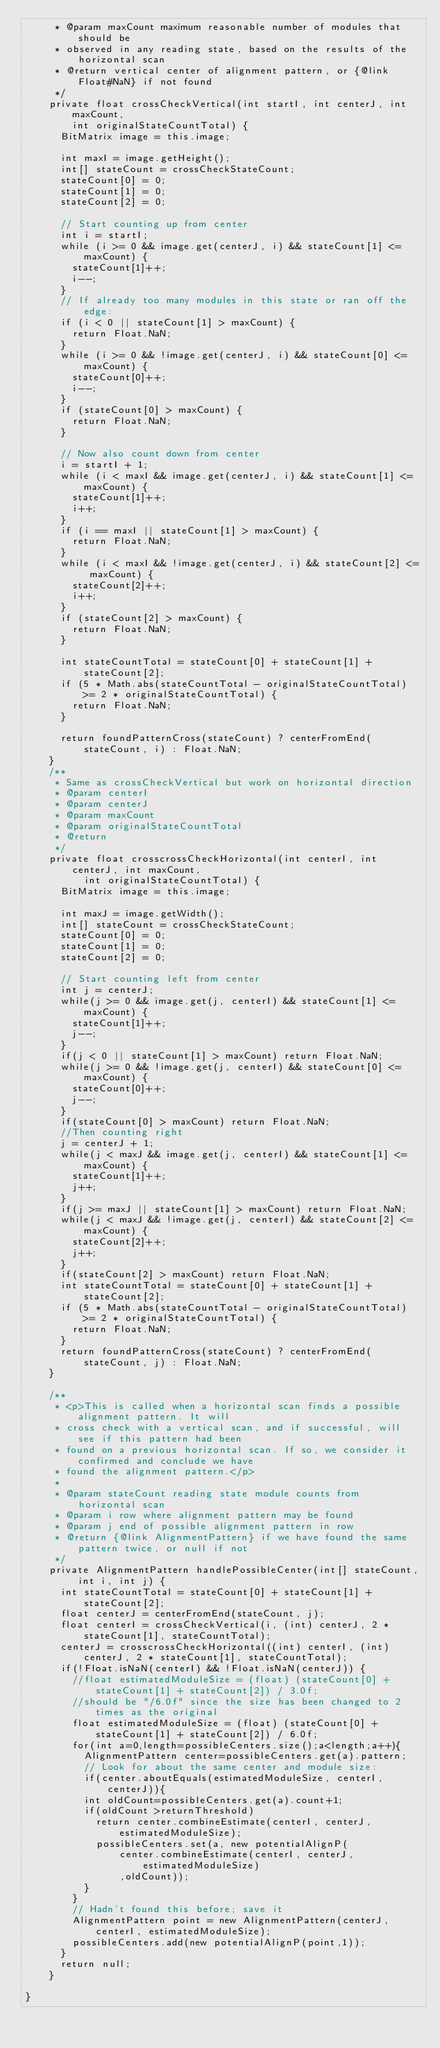Convert code to text. <code><loc_0><loc_0><loc_500><loc_500><_Java_>	   * @param maxCount maximum reasonable number of modules that should be
	   * observed in any reading state, based on the results of the horizontal scan
	   * @return vertical center of alignment pattern, or {@link Float#NaN} if not found
	   */
	  private float crossCheckVertical(int startI, int centerJ, int maxCount,
	      int originalStateCountTotal) {
	    BitMatrix image = this.image;

	    int maxI = image.getHeight();
	    int[] stateCount = crossCheckStateCount;
	    stateCount[0] = 0;
	    stateCount[1] = 0;
	    stateCount[2] = 0;

	    // Start counting up from center
	    int i = startI;
	    while (i >= 0 && image.get(centerJ, i) && stateCount[1] <= maxCount) {
	      stateCount[1]++;
	      i--;
	    }
	    // If already too many modules in this state or ran off the edge:
	    if (i < 0 || stateCount[1] > maxCount) {
	      return Float.NaN;
	    }
	    while (i >= 0 && !image.get(centerJ, i) && stateCount[0] <= maxCount) {
	      stateCount[0]++;
	      i--;
	    }
	    if (stateCount[0] > maxCount) {
	      return Float.NaN;
	    }

	    // Now also count down from center
	    i = startI + 1;
	    while (i < maxI && image.get(centerJ, i) && stateCount[1] <= maxCount) {
	      stateCount[1]++;
	      i++;
	    }
	    if (i == maxI || stateCount[1] > maxCount) {
	      return Float.NaN;
	    }
	    while (i < maxI && !image.get(centerJ, i) && stateCount[2] <= maxCount) {
	      stateCount[2]++;
	      i++;
	    }
	    if (stateCount[2] > maxCount) {
	      return Float.NaN;
	    }

	    int stateCountTotal = stateCount[0] + stateCount[1] + stateCount[2];
	    if (5 * Math.abs(stateCountTotal - originalStateCountTotal) >= 2 * originalStateCountTotal) {
	      return Float.NaN;
	    }

	    return foundPatternCross(stateCount) ? centerFromEnd(stateCount, i) : Float.NaN;
	  }
	  /**
	   * Same as crossCheckVertical but work on horizontal direction
	   * @param centerI
	   * @param centerJ
	   * @param maxCount
	   * @param originalStateCountTotal
	   * @return
	   */
	  private float crosscrossCheckHorizontal(int centerI, int centerJ, int maxCount,
		      int originalStateCountTotal) {
	    BitMatrix image = this.image;

	    int maxJ = image.getWidth();
	    int[] stateCount = crossCheckStateCount;
	    stateCount[0] = 0;
	    stateCount[1] = 0;
	    stateCount[2] = 0;
	    
	    // Start counting left from center
	    int j = centerJ;
	    while(j >= 0 && image.get(j, centerI) && stateCount[1] <= maxCount) {
	      stateCount[1]++;
	      j--;
	    }
	    if(j < 0 || stateCount[1] > maxCount) return Float.NaN;
	    while(j >= 0 && !image.get(j, centerI) && stateCount[0] <= maxCount) {
	      stateCount[0]++;
	      j--;
	    }
	    if(stateCount[0] > maxCount) return Float.NaN;
	    //Then counting right
	    j = centerJ + 1;
	    while(j < maxJ && image.get(j, centerI) && stateCount[1] <= maxCount) {
	      stateCount[1]++;
	      j++;
	    }
	    if(j >= maxJ || stateCount[1] > maxCount) return Float.NaN;
	    while(j < maxJ && !image.get(j, centerI) && stateCount[2] <= maxCount) {
	      stateCount[2]++;
	      j++;
	    }
	    if(stateCount[2] > maxCount) return Float.NaN;
	    int stateCountTotal = stateCount[0] + stateCount[1] + stateCount[2];
	    if (5 * Math.abs(stateCountTotal - originalStateCountTotal) >= 2 * originalStateCountTotal) {
	      return Float.NaN;
	    }
	    return foundPatternCross(stateCount) ? centerFromEnd(stateCount, j) : Float.NaN;
	  }

	  /**
	   * <p>This is called when a horizontal scan finds a possible alignment pattern. It will
	   * cross check with a vertical scan, and if successful, will see if this pattern had been
	   * found on a previous horizontal scan. If so, we consider it confirmed and conclude we have
	   * found the alignment pattern.</p>
	   *
	   * @param stateCount reading state module counts from horizontal scan
	   * @param i row where alignment pattern may be found
	   * @param j end of possible alignment pattern in row
	   * @return {@link AlignmentPattern} if we have found the same pattern twice, or null if not
	   */
	  private AlignmentPattern handlePossibleCenter(int[] stateCount, int i, int j) {
	    int stateCountTotal = stateCount[0] + stateCount[1] + stateCount[2];
	    float centerJ = centerFromEnd(stateCount, j);
	    float centerI = crossCheckVertical(i, (int) centerJ, 2 * stateCount[1], stateCountTotal);
	    centerJ = crosscrossCheckHorizontal((int) centerI, (int) centerJ, 2 * stateCount[1], stateCountTotal);
	    if(!Float.isNaN(centerI) && !Float.isNaN(centerJ)) {
	      //float estimatedModuleSize = (float) (stateCount[0] + stateCount[1] + stateCount[2]) / 3.0f;
	      //should be "/6.0f" since the size has been changed to 2 times as the original
	      float estimatedModuleSize = (float) (stateCount[0] + stateCount[1] + stateCount[2]) / 6.0f;
	      for(int a=0,length=possibleCenters.size();a<length;a++){
	    	  AlignmentPattern center=possibleCenters.get(a).pattern;
	    	  // Look for about the same center and module size:
	    	  if(center.aboutEquals(estimatedModuleSize, centerI, centerJ)){
	    		int oldCount=possibleCenters.get(a).count+1;
	    		if(oldCount >returnThreshold) 
	    			return center.combineEstimate(centerI, centerJ, estimatedModuleSize);
	        	possibleCenters.set(a, new potentialAlignP(
	        			center.combineEstimate(centerI, centerJ, estimatedModuleSize)
	        			,oldCount));
	    	  }
	      }
	      // Hadn't found this before; save it
	      AlignmentPattern point = new AlignmentPattern(centerJ, centerI, estimatedModuleSize);
	      possibleCenters.add(new potentialAlignP(point,1));
	    }
	    return null;
	  }

}</code> 